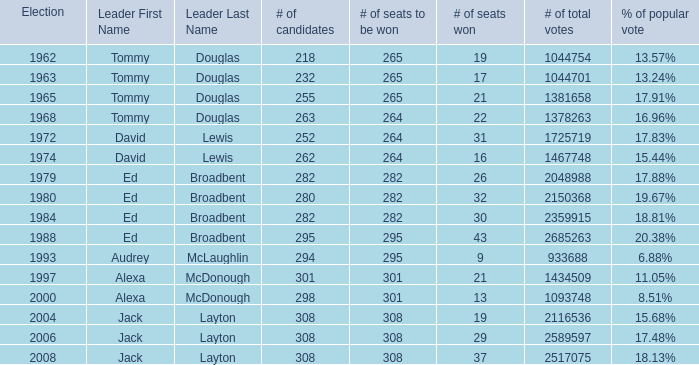Name the number of leaders for % of popular vote being 11.05% 1.0. 